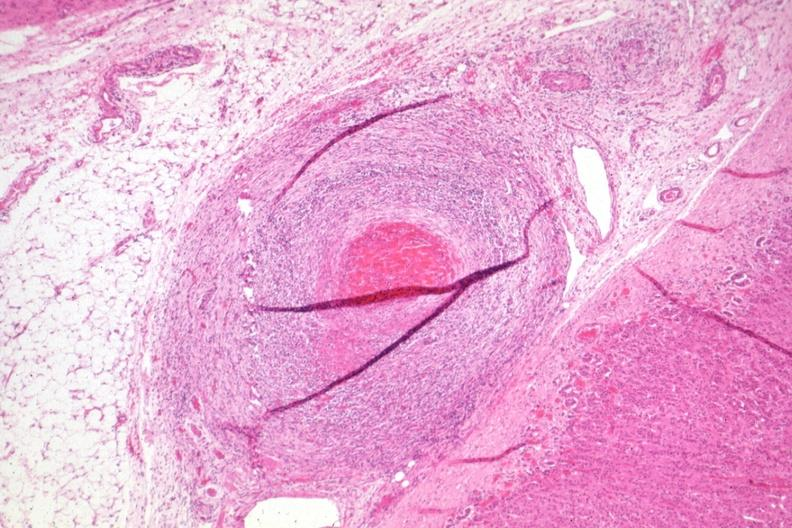what has outside adrenal capsule section?
Answer the question using a single word or phrase. Folds 